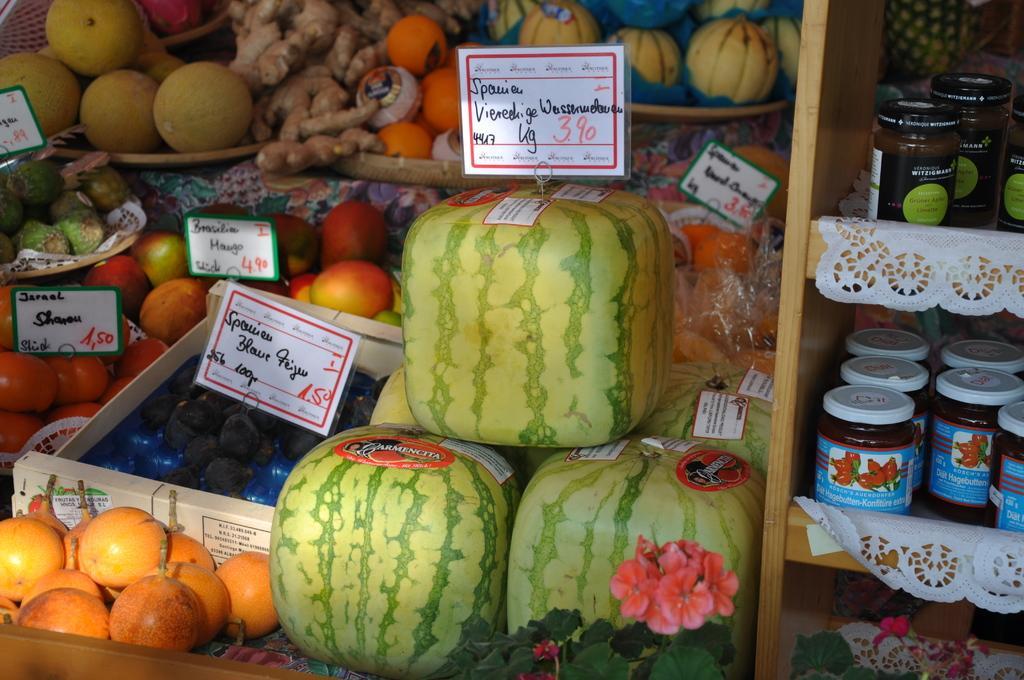Please provide a concise description of this image. In the image in the center, we can see the racks, papers, baskets, banners and different types of fruits like watermelons, apples, oranges etc. 